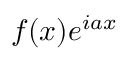Convert formula to latex. <formula><loc_0><loc_0><loc_500><loc_500>f ( x ) e ^ { i a x }</formula> 